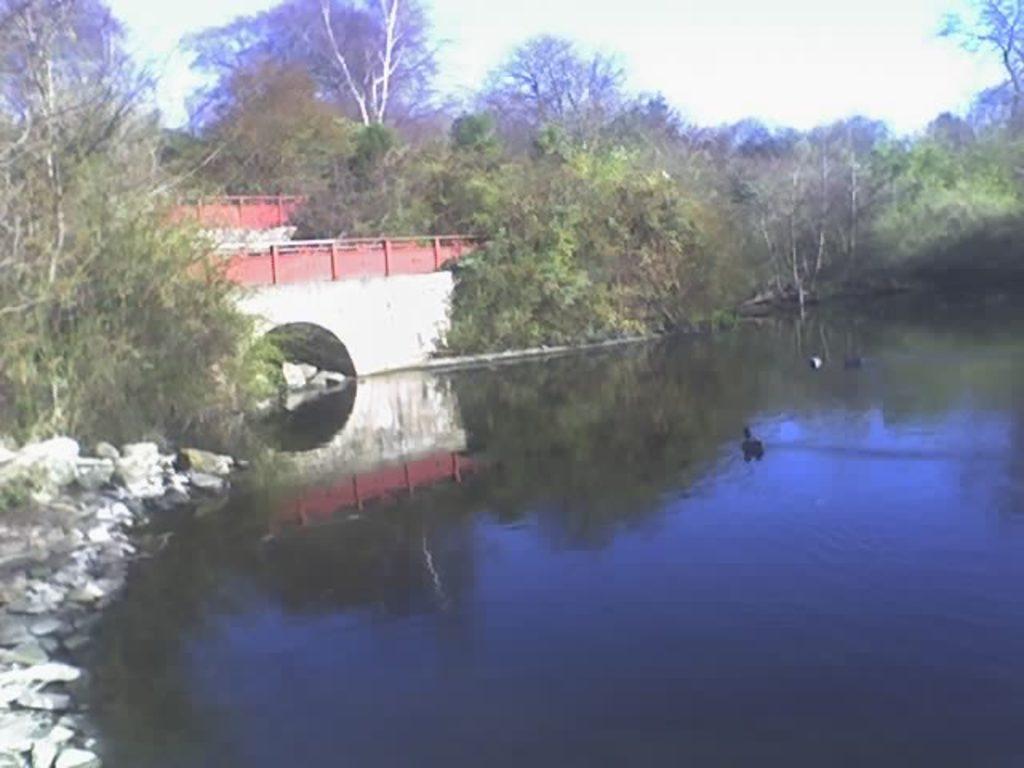Could you give a brief overview of what you see in this image? In the foreground of this image, there are trees, a pond, stones, a bridge and the sky. 